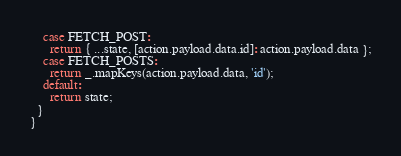Convert code to text. <code><loc_0><loc_0><loc_500><loc_500><_JavaScript_>    case FETCH_POST:
      return { ...state, [action.payload.data.id]: action.payload.data };
    case FETCH_POSTS:
      return _.mapKeys(action.payload.data, 'id');
    default:
      return state;
  }
}</code> 